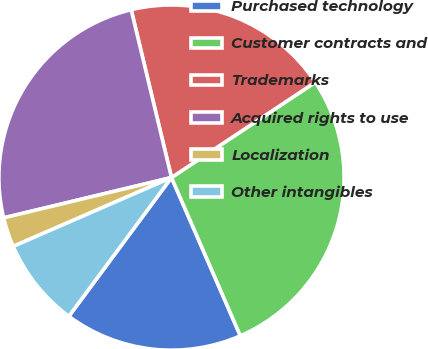<chart> <loc_0><loc_0><loc_500><loc_500><pie_chart><fcel>Purchased technology<fcel>Customer contracts and<fcel>Trademarks<fcel>Acquired rights to use<fcel>Localization<fcel>Other intangibles<nl><fcel>16.67%<fcel>27.78%<fcel>19.44%<fcel>25.0%<fcel>2.78%<fcel>8.33%<nl></chart> 